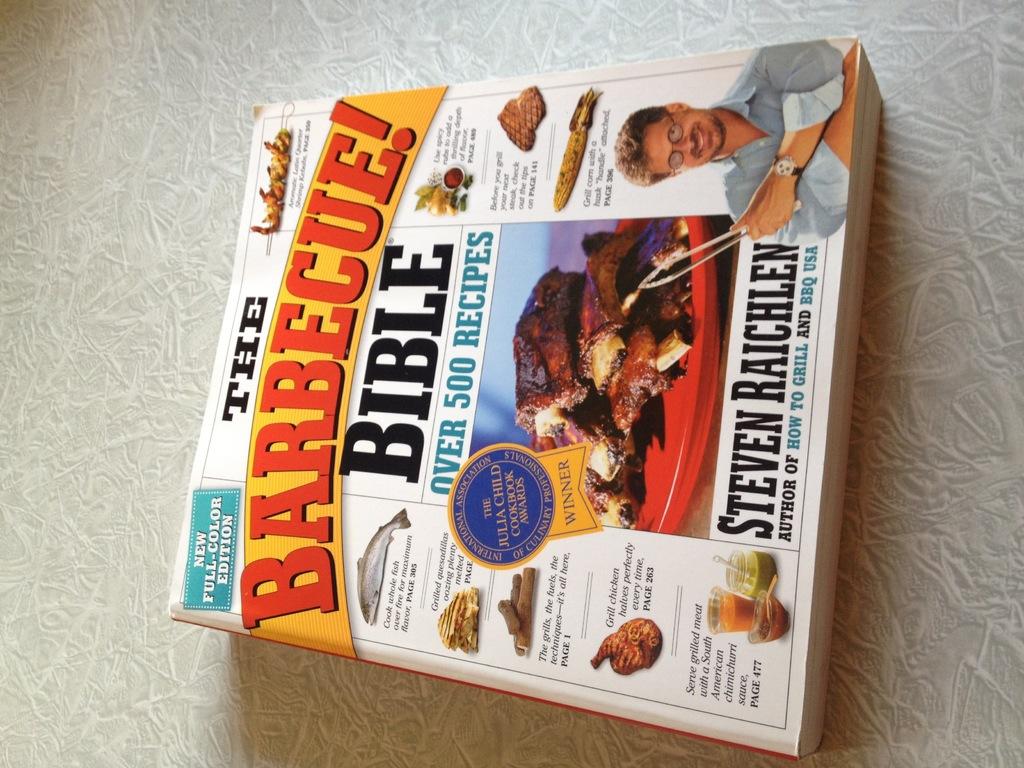Are there a lot of recipes in this book?
Keep it short and to the point. Yes. What type of bible is this?
Provide a short and direct response. Barbecue. 